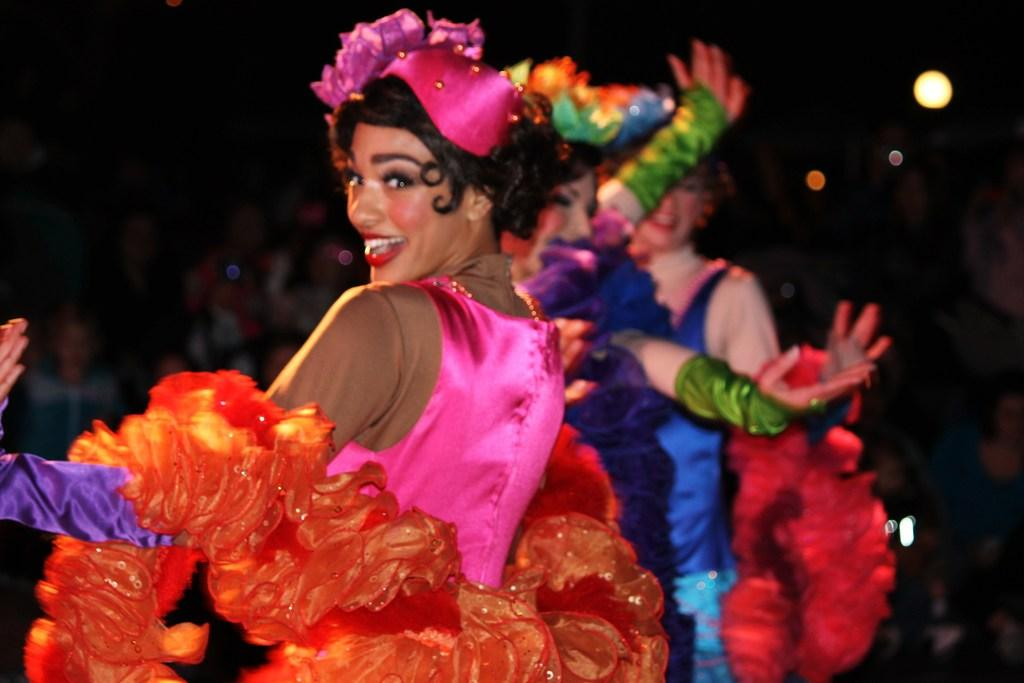How many women are in the image? There are three women in the image. What are the women wearing? The women are wearing fancy dresses. What expression do the women have? The women are smiling. What can be seen in the background of the image? There is a group of people and lights visible in the background of the image. How would you describe the lighting in the image? The background of the image is dark, but there are lights visible. What type of drum can be heard in the image? There is no drum present in the image, and therefore no sound can be heard. 